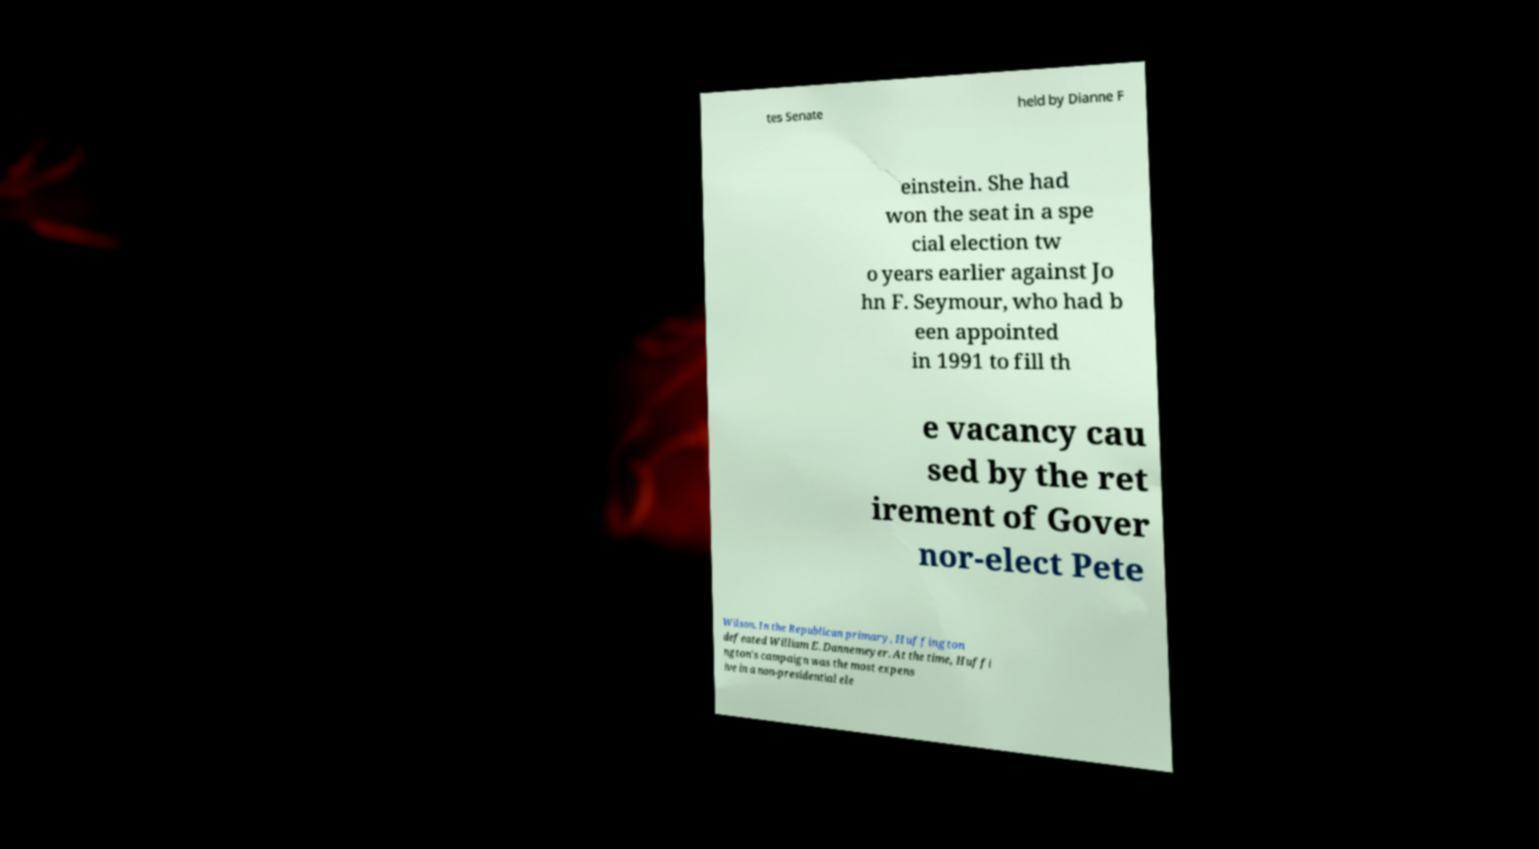For documentation purposes, I need the text within this image transcribed. Could you provide that? tes Senate held by Dianne F einstein. She had won the seat in a spe cial election tw o years earlier against Jo hn F. Seymour, who had b een appointed in 1991 to fill th e vacancy cau sed by the ret irement of Gover nor-elect Pete Wilson. In the Republican primary, Huffington defeated William E. Dannemeyer. At the time, Huffi ngton's campaign was the most expens ive in a non-presidential ele 